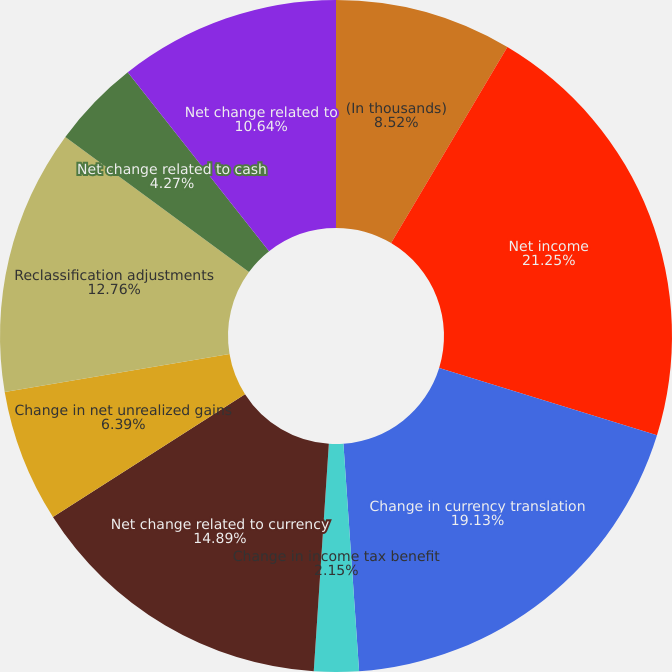<chart> <loc_0><loc_0><loc_500><loc_500><pie_chart><fcel>(In thousands)<fcel>Net income<fcel>Change in currency translation<fcel>Change in income tax benefit<fcel>Net change related to currency<fcel>Change in net unrealized gains<fcel>Reclassification adjustments<fcel>Net change related to cash<fcel>Net change related to<nl><fcel>8.52%<fcel>21.26%<fcel>19.13%<fcel>2.15%<fcel>14.89%<fcel>6.39%<fcel>12.76%<fcel>4.27%<fcel>10.64%<nl></chart> 